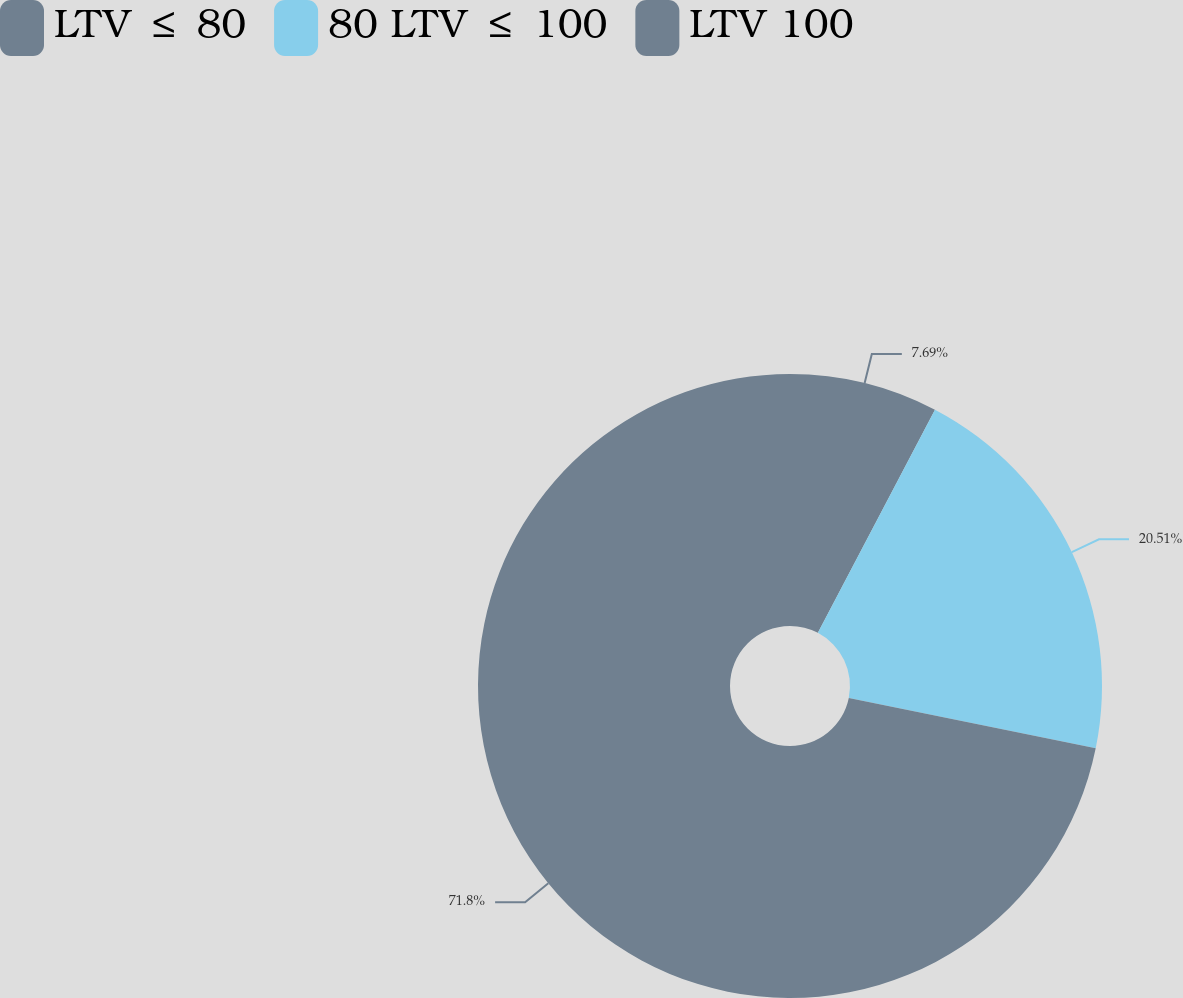<chart> <loc_0><loc_0><loc_500><loc_500><pie_chart><fcel>LTV ≤ 80<fcel>80 LTV ≤ 100<fcel>LTV 100<nl><fcel>7.69%<fcel>20.51%<fcel>71.79%<nl></chart> 